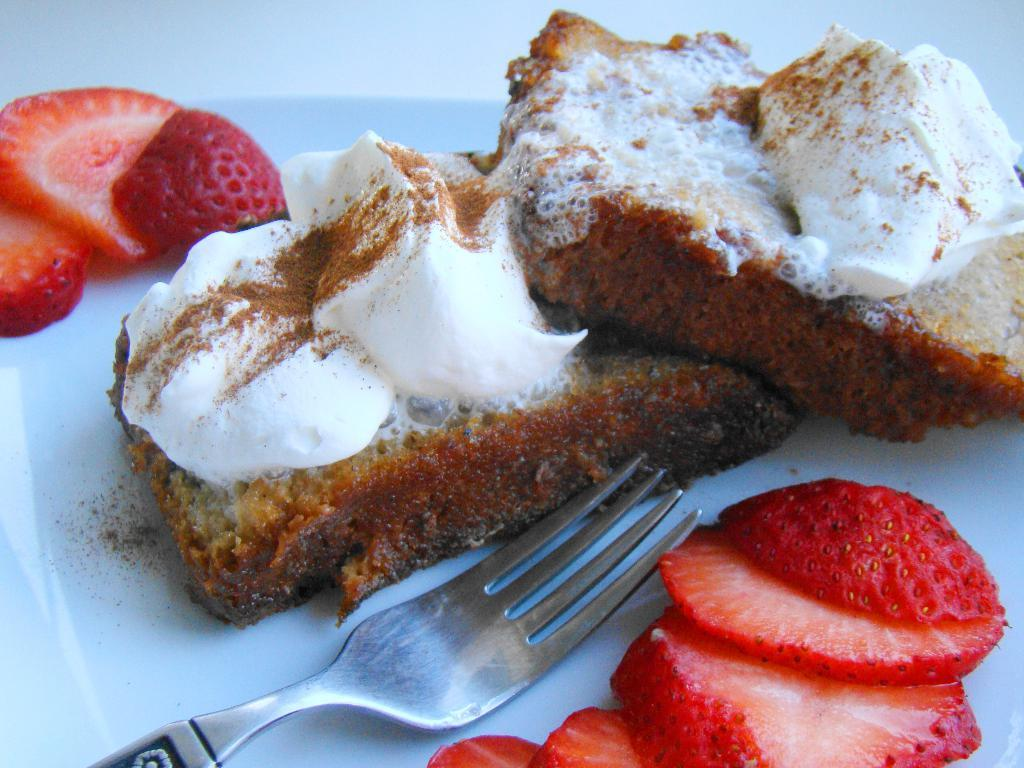What type of objects can be seen in the image? There are food items and a fork in the image. What might be used to eat the food items in the image? The fork in the image can be used to eat the food items. Where are the food items and fork located? The food items and fork are placed on a surface. What type of structure can be seen in the background of the image? There is no structure visible in the image; it only shows food items and a fork on a surface. 